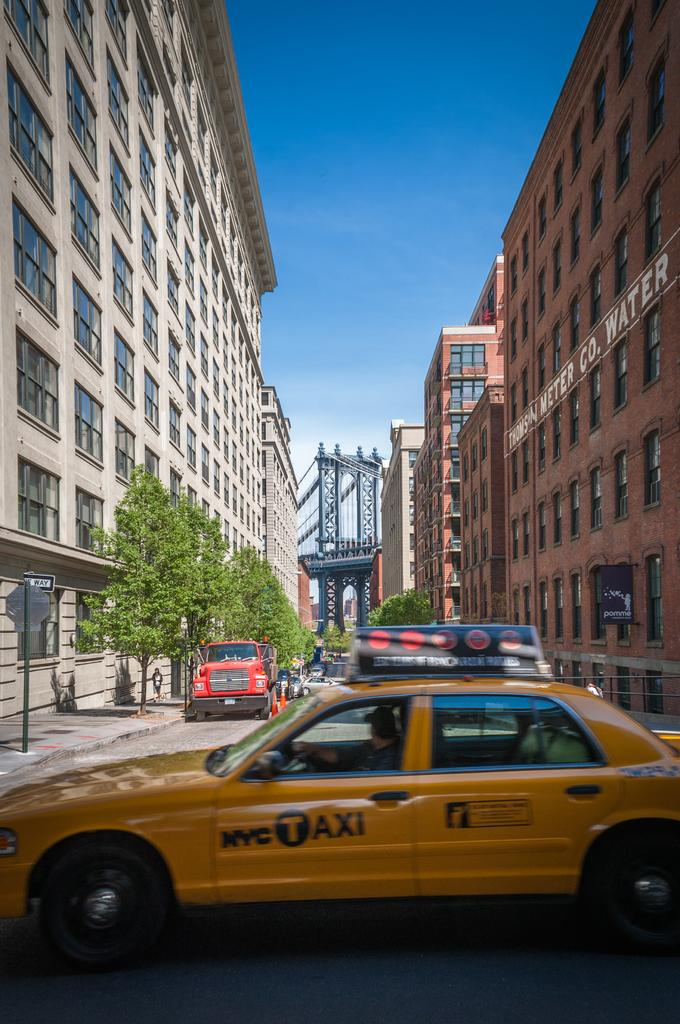<image>
Provide a brief description of the given image. A yellow vehicle in a street with NYC Taxi on the side. 